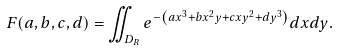Convert formula to latex. <formula><loc_0><loc_0><loc_500><loc_500>F ( a , b , c , d ) = \iint _ { D _ { R } } e ^ { - \left ( a x ^ { 3 } + b x ^ { 2 } y + c x y ^ { 2 } + d y ^ { 3 } \right ) } d x d y .</formula> 